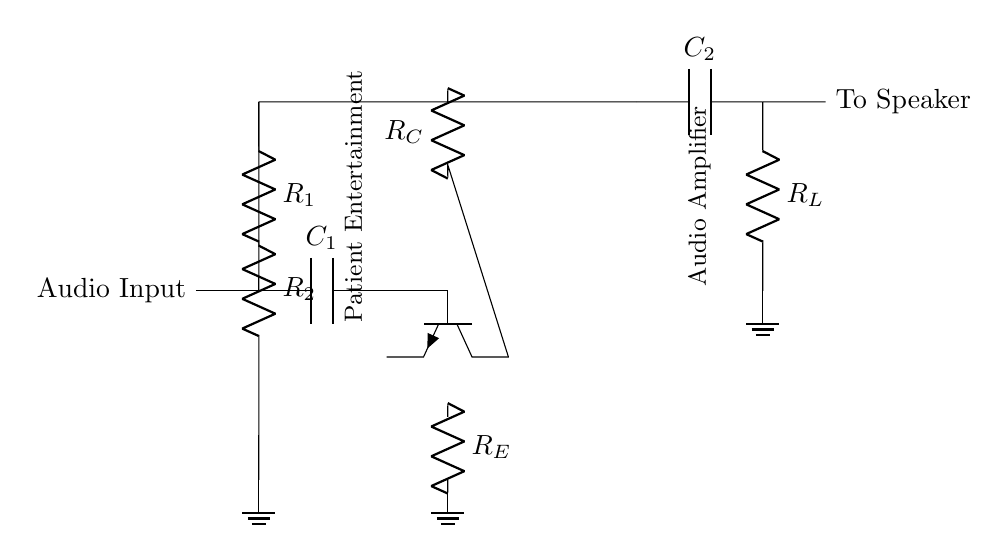What is the main purpose of this circuit? The main purpose is to amplify audio signals for patient entertainment systems. This is evident from the labeling in the circuit diagram, which explicitly states "Patient Entertainment" and "Audio Amplifier".
Answer: Audio amplification What type of transistor is used in this circuit? The circuit uses an NPN transistor, as indicated by the npn symbol in the circuit diagram.
Answer: NPN How many capacitors are present in the circuit? There are two capacitors present in the circuit, identified as C1 and C2, which are used for coupling and output filtering.
Answer: Two What role does the resistor R_E serve in this circuit? Resistor R_E is the emitter resistor, which helps stabilize the transistor's operation and set the output current level. This is a typical function for emitter resistors in amplifiers.
Answer: Stabilization What is the function of the capacitor C_1? Capacitor C_1 couples the audio input signal to the transistor's base while blocking DC components, allowing only AC signals to pass through. This ensures the transistor operates correctly for audio signals.
Answer: Coupling What do resistors R_1 and R_2 do in this circuit? Resistors R_1 and R_2 form a voltage divider that provides the base biasing for the transistor. Proper biasing is crucial for keeping the transistor in the active region for amplification.
Answer: Biasing the transistor What is the output of this circuit connected to? The output is connected to a speaker, as clearly indicated by the label "To Speaker" in the circuit diagram, which shows that the amplified signal will drive the speaker.
Answer: Speaker 